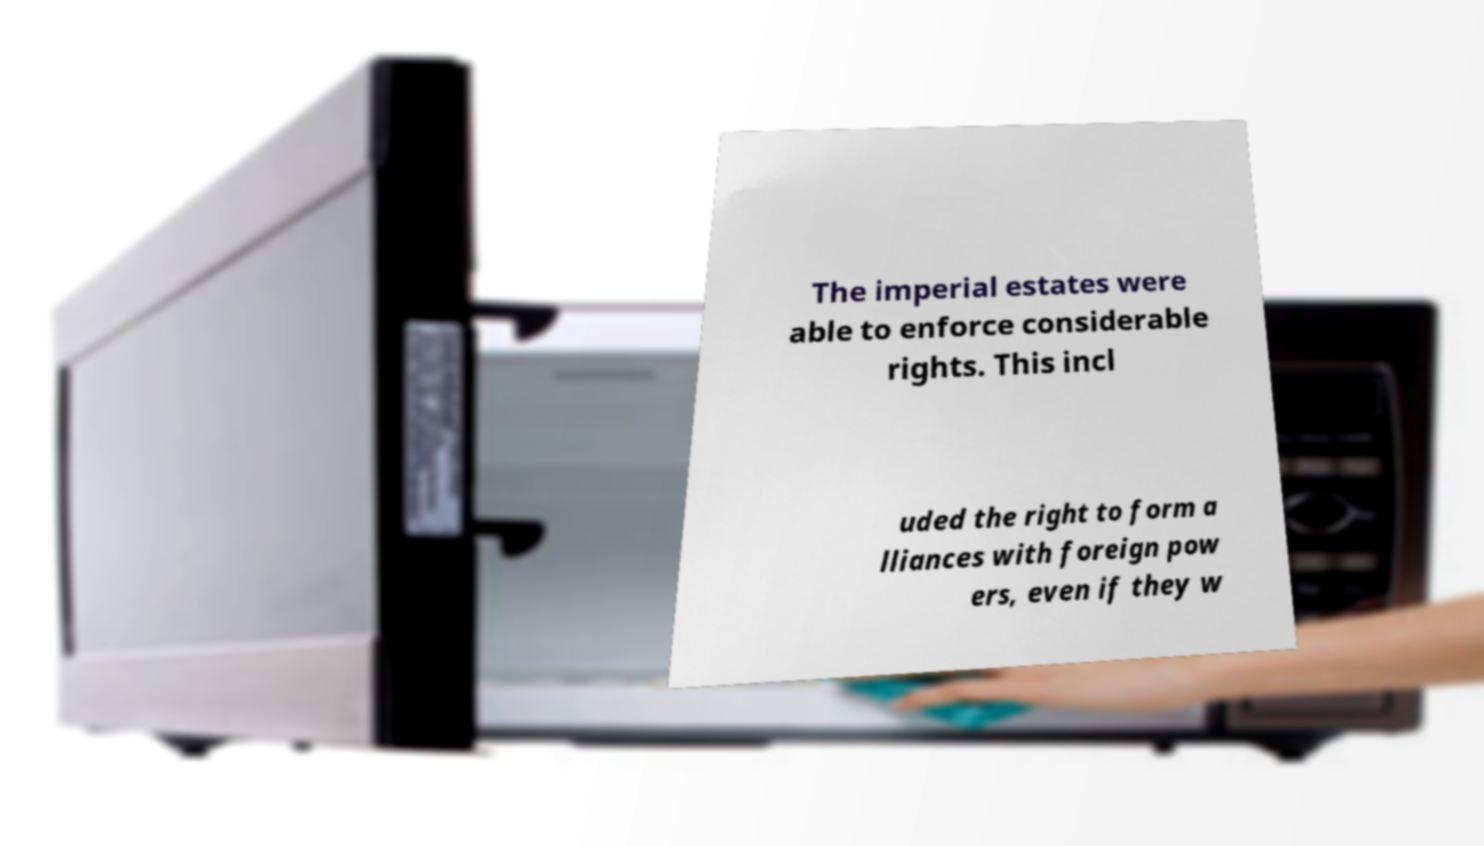Please read and relay the text visible in this image. What does it say? The imperial estates were able to enforce considerable rights. This incl uded the right to form a lliances with foreign pow ers, even if they w 